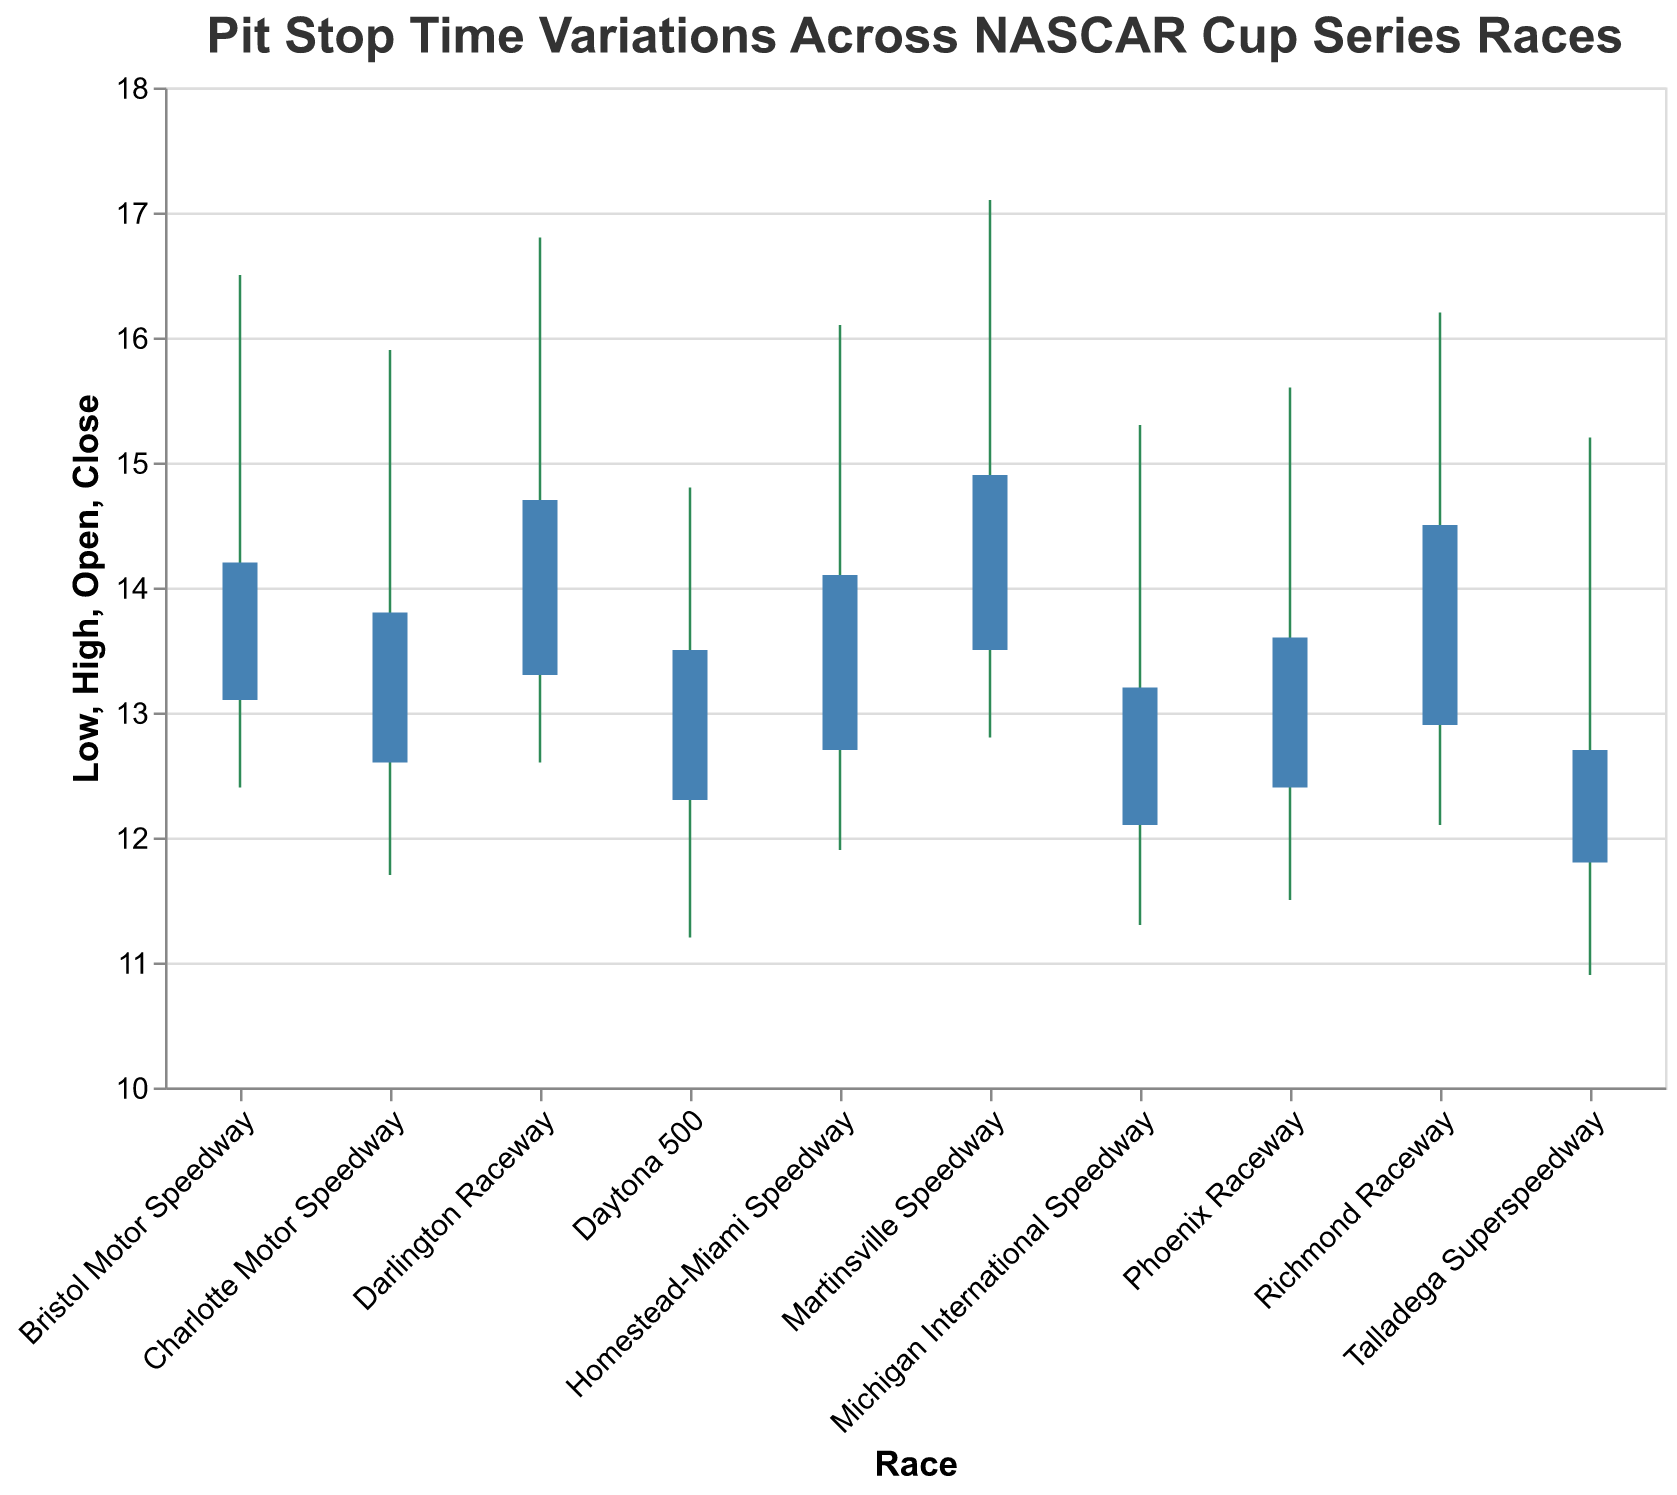What is the title of the figure? The title is printed at the top of the figure in a larger font size. It states the main topic or purpose of the visualization.
Answer: Pit Stop Time Variations Across NASCAR Cup Series Races Which race has the highest pit stop time? To find the race with the highest pit stop time, look for the highest value in the "High" field among all bars.
Answer: Martinsville Speedway What is the pit stop time range for Bristol Motor Speedway? The range is given by the difference between the highest (High) and lowest (Low) values. For Bristol Motor Speedway, check the corresponding values.
Answer: 4.1 seconds (16.5 - 12.4) Which race had the greatest difference in pit stop times from open to close? Compare the difference between "Open" and "Close" times for each race, then identify the greatest among them.
Answer: Bristol Motor Speedway (16.5 - 12.4 = 4.1 seconds) What is the color used for the bars representing the pit stop times from open to close? The bars are visually distinct and their color is specified in the figure's design.
Answer: Blue On average, did the close times tend to be higher, lower, or the same as the open times across races? Compute the average difference between "Close" and "Open" times for all races. Check if the average result is positive, negative, or zero.
Answer: Higher Compare the pit stop time variations between Daytona 500 and Talladega Superspeedway. Which has a larger variation? Calculate the variation for each race defined as (High - Low) and compare their values.
Answer: Talladega Superspeedway (4.3 vs. 3.6 seconds) How many races showed a higher close time compared to open time? Count the races where the "Close" value of pit stop time is greater than the "Open" value.
Answer: 9 races What is the mid-point time for the pit stops at Homestead-Miami Speedway? The mid-point can be determined by averaging the "Open" and "Close" times. Calculate (12.7 + 14.1) / 2.
Answer: 13.4 seconds Which race has the closest "Open" and "Close" times? Find the race with the smallest difference between the "Open" and "Close" values.
Answer: Talladega Superspeedway (12.7 - 11.8 = 0.9 seconds) 